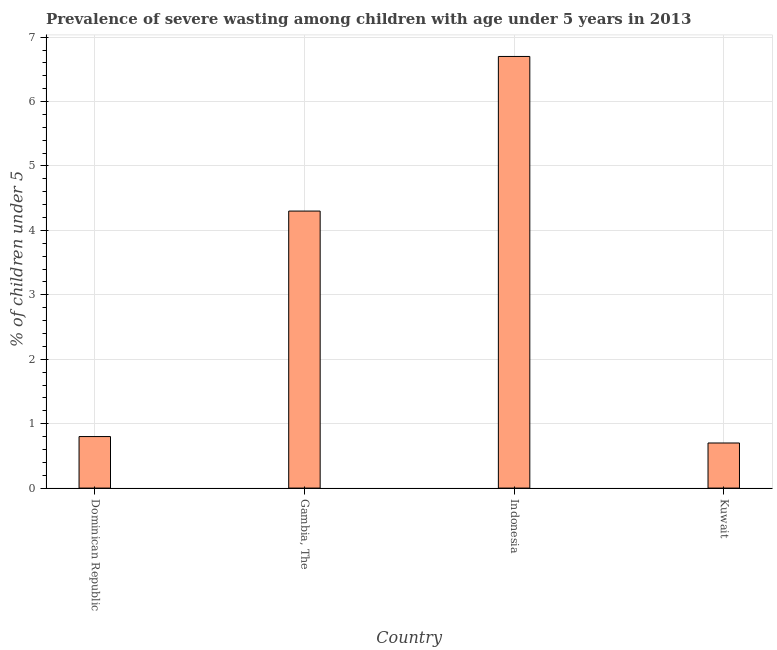Does the graph contain grids?
Offer a very short reply. Yes. What is the title of the graph?
Offer a terse response. Prevalence of severe wasting among children with age under 5 years in 2013. What is the label or title of the Y-axis?
Offer a terse response.  % of children under 5. What is the prevalence of severe wasting in Indonesia?
Keep it short and to the point. 6.7. Across all countries, what is the maximum prevalence of severe wasting?
Your answer should be compact. 6.7. Across all countries, what is the minimum prevalence of severe wasting?
Your response must be concise. 0.7. In which country was the prevalence of severe wasting minimum?
Provide a short and direct response. Kuwait. What is the sum of the prevalence of severe wasting?
Give a very brief answer. 12.5. What is the difference between the prevalence of severe wasting in Dominican Republic and Indonesia?
Your answer should be compact. -5.9. What is the average prevalence of severe wasting per country?
Keep it short and to the point. 3.12. What is the median prevalence of severe wasting?
Provide a short and direct response. 2.55. What is the ratio of the prevalence of severe wasting in Gambia, The to that in Indonesia?
Ensure brevity in your answer.  0.64. Is the prevalence of severe wasting in Dominican Republic less than that in Kuwait?
Provide a short and direct response. No. What is the difference between the highest and the second highest prevalence of severe wasting?
Make the answer very short. 2.4. Is the sum of the prevalence of severe wasting in Dominican Republic and Indonesia greater than the maximum prevalence of severe wasting across all countries?
Offer a very short reply. Yes. What is the difference between the highest and the lowest prevalence of severe wasting?
Offer a very short reply. 6. In how many countries, is the prevalence of severe wasting greater than the average prevalence of severe wasting taken over all countries?
Give a very brief answer. 2. What is the difference between two consecutive major ticks on the Y-axis?
Offer a very short reply. 1. Are the values on the major ticks of Y-axis written in scientific E-notation?
Provide a short and direct response. No. What is the  % of children under 5 of Dominican Republic?
Ensure brevity in your answer.  0.8. What is the  % of children under 5 in Gambia, The?
Provide a succinct answer. 4.3. What is the  % of children under 5 of Indonesia?
Your answer should be compact. 6.7. What is the  % of children under 5 in Kuwait?
Your answer should be compact. 0.7. What is the difference between the  % of children under 5 in Dominican Republic and Gambia, The?
Your answer should be compact. -3.5. What is the difference between the  % of children under 5 in Gambia, The and Kuwait?
Your answer should be compact. 3.6. What is the ratio of the  % of children under 5 in Dominican Republic to that in Gambia, The?
Ensure brevity in your answer.  0.19. What is the ratio of the  % of children under 5 in Dominican Republic to that in Indonesia?
Your answer should be compact. 0.12. What is the ratio of the  % of children under 5 in Dominican Republic to that in Kuwait?
Your answer should be compact. 1.14. What is the ratio of the  % of children under 5 in Gambia, The to that in Indonesia?
Provide a short and direct response. 0.64. What is the ratio of the  % of children under 5 in Gambia, The to that in Kuwait?
Your response must be concise. 6.14. What is the ratio of the  % of children under 5 in Indonesia to that in Kuwait?
Provide a succinct answer. 9.57. 